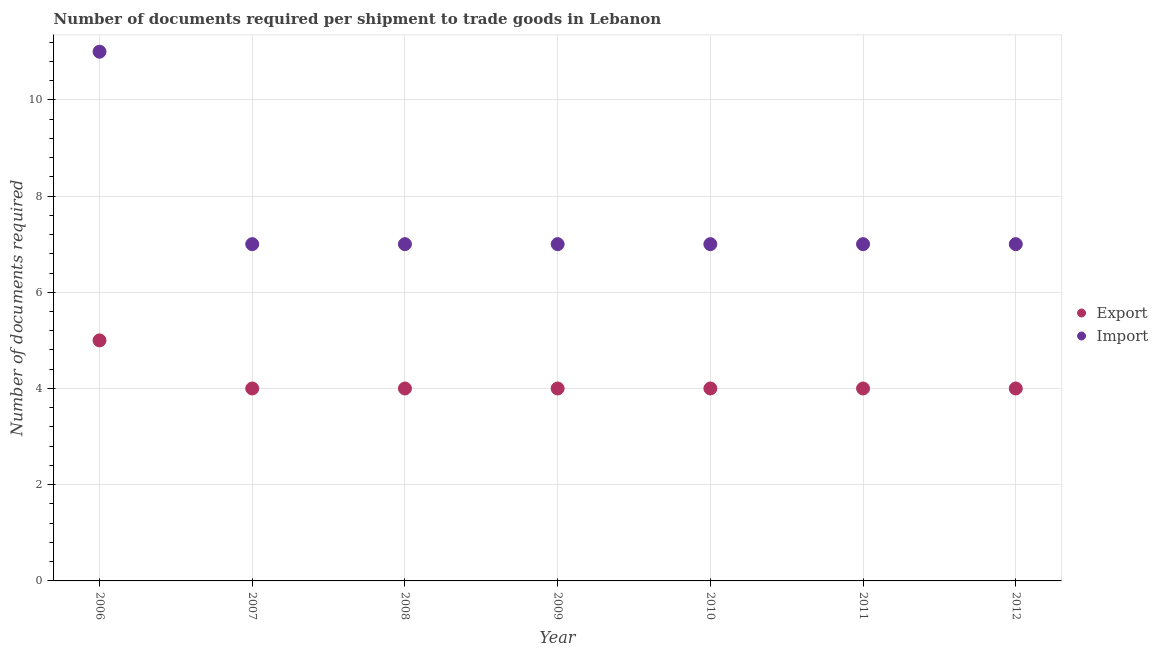How many different coloured dotlines are there?
Offer a very short reply. 2. Is the number of dotlines equal to the number of legend labels?
Provide a succinct answer. Yes. What is the number of documents required to import goods in 2011?
Provide a succinct answer. 7. Across all years, what is the maximum number of documents required to export goods?
Keep it short and to the point. 5. Across all years, what is the minimum number of documents required to export goods?
Your answer should be very brief. 4. In which year was the number of documents required to import goods maximum?
Provide a short and direct response. 2006. What is the total number of documents required to import goods in the graph?
Offer a very short reply. 53. What is the difference between the number of documents required to export goods in 2010 and that in 2012?
Provide a short and direct response. 0. What is the difference between the number of documents required to export goods in 2012 and the number of documents required to import goods in 2009?
Your response must be concise. -3. What is the average number of documents required to import goods per year?
Make the answer very short. 7.57. In the year 2009, what is the difference between the number of documents required to export goods and number of documents required to import goods?
Offer a terse response. -3. What is the difference between the highest and the lowest number of documents required to import goods?
Make the answer very short. 4. Is the sum of the number of documents required to import goods in 2006 and 2011 greater than the maximum number of documents required to export goods across all years?
Your response must be concise. Yes. Does the number of documents required to export goods monotonically increase over the years?
Make the answer very short. No. Is the number of documents required to export goods strictly less than the number of documents required to import goods over the years?
Your answer should be compact. Yes. How many dotlines are there?
Offer a very short reply. 2. How many years are there in the graph?
Your response must be concise. 7. Are the values on the major ticks of Y-axis written in scientific E-notation?
Your answer should be very brief. No. Does the graph contain any zero values?
Give a very brief answer. No. Does the graph contain grids?
Give a very brief answer. Yes. What is the title of the graph?
Provide a short and direct response. Number of documents required per shipment to trade goods in Lebanon. Does "Investment in Telecom" appear as one of the legend labels in the graph?
Ensure brevity in your answer.  No. What is the label or title of the X-axis?
Your answer should be compact. Year. What is the label or title of the Y-axis?
Provide a short and direct response. Number of documents required. What is the Number of documents required of Export in 2006?
Provide a short and direct response. 5. What is the Number of documents required of Import in 2008?
Provide a succinct answer. 7. What is the Number of documents required in Export in 2009?
Your response must be concise. 4. What is the Number of documents required in Export in 2010?
Give a very brief answer. 4. What is the Number of documents required in Export in 2011?
Provide a short and direct response. 4. What is the Number of documents required of Import in 2011?
Keep it short and to the point. 7. What is the Number of documents required of Export in 2012?
Give a very brief answer. 4. What is the Number of documents required in Import in 2012?
Provide a succinct answer. 7. Across all years, what is the maximum Number of documents required of Import?
Offer a terse response. 11. Across all years, what is the minimum Number of documents required in Export?
Keep it short and to the point. 4. What is the total Number of documents required in Import in the graph?
Your answer should be compact. 53. What is the difference between the Number of documents required in Export in 2006 and that in 2007?
Your response must be concise. 1. What is the difference between the Number of documents required in Import in 2006 and that in 2007?
Offer a very short reply. 4. What is the difference between the Number of documents required of Import in 2006 and that in 2008?
Your answer should be compact. 4. What is the difference between the Number of documents required of Export in 2006 and that in 2010?
Your response must be concise. 1. What is the difference between the Number of documents required in Import in 2006 and that in 2011?
Ensure brevity in your answer.  4. What is the difference between the Number of documents required in Export in 2006 and that in 2012?
Offer a very short reply. 1. What is the difference between the Number of documents required in Import in 2006 and that in 2012?
Offer a very short reply. 4. What is the difference between the Number of documents required of Export in 2007 and that in 2008?
Provide a succinct answer. 0. What is the difference between the Number of documents required in Import in 2007 and that in 2008?
Your answer should be very brief. 0. What is the difference between the Number of documents required in Import in 2007 and that in 2009?
Keep it short and to the point. 0. What is the difference between the Number of documents required of Export in 2007 and that in 2010?
Provide a short and direct response. 0. What is the difference between the Number of documents required in Import in 2007 and that in 2010?
Offer a terse response. 0. What is the difference between the Number of documents required in Import in 2007 and that in 2011?
Provide a succinct answer. 0. What is the difference between the Number of documents required of Export in 2008 and that in 2010?
Provide a short and direct response. 0. What is the difference between the Number of documents required in Export in 2008 and that in 2011?
Provide a succinct answer. 0. What is the difference between the Number of documents required in Export in 2009 and that in 2010?
Make the answer very short. 0. What is the difference between the Number of documents required of Export in 2009 and that in 2011?
Your response must be concise. 0. What is the difference between the Number of documents required in Export in 2009 and that in 2012?
Give a very brief answer. 0. What is the difference between the Number of documents required in Import in 2009 and that in 2012?
Offer a very short reply. 0. What is the difference between the Number of documents required of Export in 2010 and that in 2011?
Offer a terse response. 0. What is the difference between the Number of documents required of Import in 2010 and that in 2011?
Provide a short and direct response. 0. What is the difference between the Number of documents required of Export in 2010 and that in 2012?
Provide a succinct answer. 0. What is the difference between the Number of documents required of Import in 2010 and that in 2012?
Your response must be concise. 0. What is the difference between the Number of documents required of Export in 2011 and that in 2012?
Keep it short and to the point. 0. What is the difference between the Number of documents required in Export in 2006 and the Number of documents required in Import in 2009?
Give a very brief answer. -2. What is the difference between the Number of documents required in Export in 2007 and the Number of documents required in Import in 2011?
Give a very brief answer. -3. What is the difference between the Number of documents required in Export in 2007 and the Number of documents required in Import in 2012?
Make the answer very short. -3. What is the difference between the Number of documents required in Export in 2008 and the Number of documents required in Import in 2012?
Your answer should be compact. -3. What is the difference between the Number of documents required of Export in 2009 and the Number of documents required of Import in 2011?
Your answer should be very brief. -3. What is the difference between the Number of documents required of Export in 2009 and the Number of documents required of Import in 2012?
Give a very brief answer. -3. What is the difference between the Number of documents required in Export in 2010 and the Number of documents required in Import in 2011?
Provide a succinct answer. -3. What is the difference between the Number of documents required in Export in 2010 and the Number of documents required in Import in 2012?
Give a very brief answer. -3. What is the difference between the Number of documents required in Export in 2011 and the Number of documents required in Import in 2012?
Offer a very short reply. -3. What is the average Number of documents required of Export per year?
Your answer should be compact. 4.14. What is the average Number of documents required of Import per year?
Provide a succinct answer. 7.57. In the year 2006, what is the difference between the Number of documents required of Export and Number of documents required of Import?
Your answer should be very brief. -6. In the year 2007, what is the difference between the Number of documents required in Export and Number of documents required in Import?
Offer a very short reply. -3. In the year 2008, what is the difference between the Number of documents required in Export and Number of documents required in Import?
Provide a short and direct response. -3. In the year 2011, what is the difference between the Number of documents required in Export and Number of documents required in Import?
Offer a very short reply. -3. What is the ratio of the Number of documents required of Export in 2006 to that in 2007?
Your response must be concise. 1.25. What is the ratio of the Number of documents required in Import in 2006 to that in 2007?
Keep it short and to the point. 1.57. What is the ratio of the Number of documents required of Export in 2006 to that in 2008?
Ensure brevity in your answer.  1.25. What is the ratio of the Number of documents required in Import in 2006 to that in 2008?
Provide a succinct answer. 1.57. What is the ratio of the Number of documents required of Export in 2006 to that in 2009?
Your response must be concise. 1.25. What is the ratio of the Number of documents required of Import in 2006 to that in 2009?
Ensure brevity in your answer.  1.57. What is the ratio of the Number of documents required in Export in 2006 to that in 2010?
Give a very brief answer. 1.25. What is the ratio of the Number of documents required of Import in 2006 to that in 2010?
Your response must be concise. 1.57. What is the ratio of the Number of documents required in Export in 2006 to that in 2011?
Provide a short and direct response. 1.25. What is the ratio of the Number of documents required of Import in 2006 to that in 2011?
Ensure brevity in your answer.  1.57. What is the ratio of the Number of documents required of Import in 2006 to that in 2012?
Your answer should be very brief. 1.57. What is the ratio of the Number of documents required of Export in 2007 to that in 2008?
Offer a very short reply. 1. What is the ratio of the Number of documents required in Import in 2007 to that in 2008?
Offer a very short reply. 1. What is the ratio of the Number of documents required of Export in 2007 to that in 2009?
Your response must be concise. 1. What is the ratio of the Number of documents required in Import in 2007 to that in 2009?
Offer a terse response. 1. What is the ratio of the Number of documents required of Export in 2007 to that in 2010?
Ensure brevity in your answer.  1. What is the ratio of the Number of documents required in Import in 2007 to that in 2010?
Your response must be concise. 1. What is the ratio of the Number of documents required in Import in 2007 to that in 2011?
Keep it short and to the point. 1. What is the ratio of the Number of documents required in Import in 2008 to that in 2009?
Your answer should be very brief. 1. What is the ratio of the Number of documents required in Import in 2008 to that in 2010?
Give a very brief answer. 1. What is the ratio of the Number of documents required of Export in 2008 to that in 2011?
Make the answer very short. 1. What is the ratio of the Number of documents required of Import in 2008 to that in 2011?
Your answer should be very brief. 1. What is the ratio of the Number of documents required of Import in 2008 to that in 2012?
Keep it short and to the point. 1. What is the ratio of the Number of documents required of Export in 2009 to that in 2010?
Provide a short and direct response. 1. What is the ratio of the Number of documents required of Import in 2009 to that in 2010?
Your answer should be very brief. 1. What is the ratio of the Number of documents required in Import in 2009 to that in 2012?
Your answer should be compact. 1. What is the ratio of the Number of documents required of Import in 2010 to that in 2011?
Your response must be concise. 1. What is the ratio of the Number of documents required of Export in 2010 to that in 2012?
Your answer should be very brief. 1. What is the difference between the highest and the second highest Number of documents required of Export?
Provide a succinct answer. 1. What is the difference between the highest and the lowest Number of documents required in Export?
Make the answer very short. 1. What is the difference between the highest and the lowest Number of documents required in Import?
Offer a terse response. 4. 